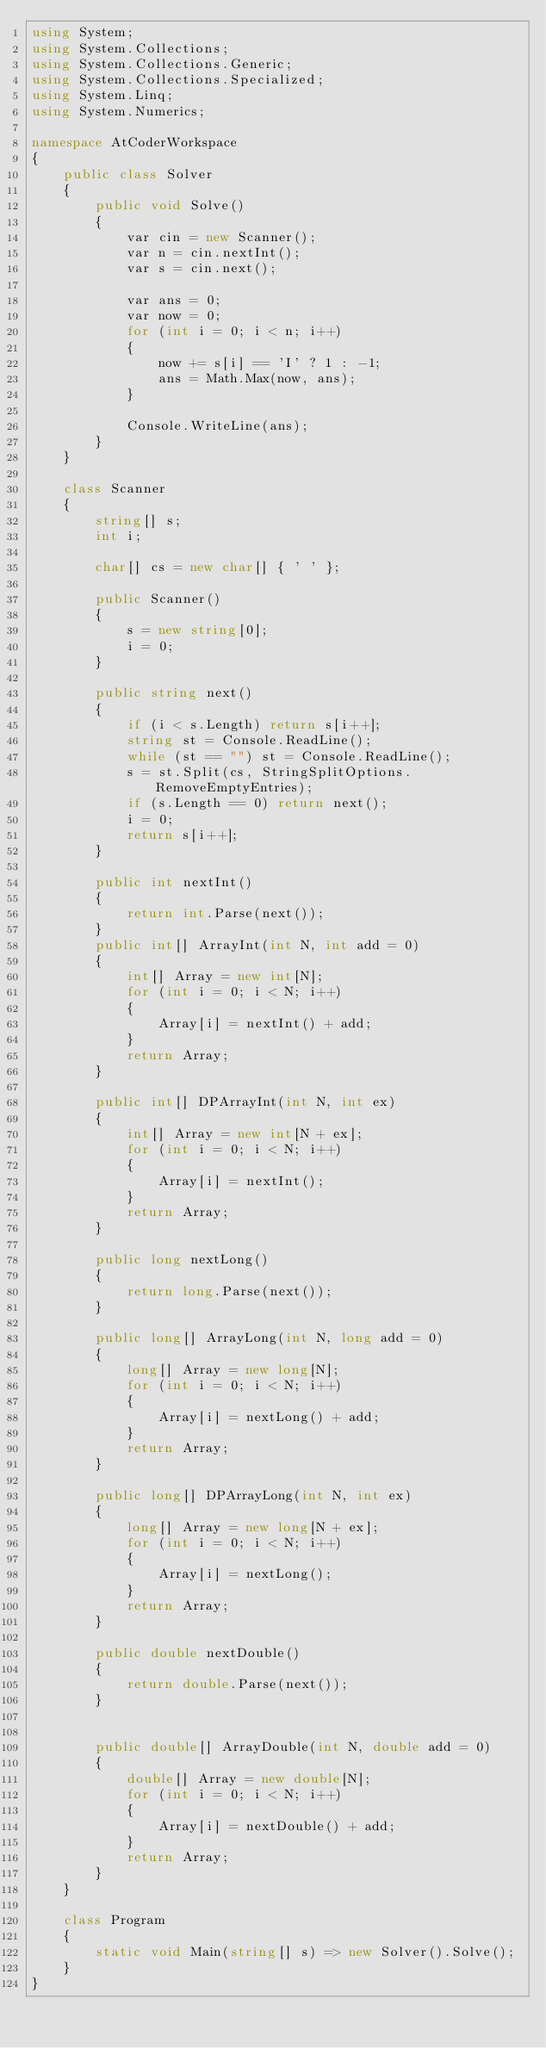<code> <loc_0><loc_0><loc_500><loc_500><_C#_>using System;
using System.Collections;
using System.Collections.Generic;
using System.Collections.Specialized;
using System.Linq;
using System.Numerics;

namespace AtCoderWorkspace
{
    public class Solver
    {
        public void Solve()
        {
            var cin = new Scanner();
            var n = cin.nextInt();
            var s = cin.next();

            var ans = 0;
            var now = 0;
            for (int i = 0; i < n; i++)
            {
                now += s[i] == 'I' ? 1 : -1;
                ans = Math.Max(now, ans);
            }

            Console.WriteLine(ans);
        }
    }    

    class Scanner
    {
        string[] s;
        int i;

        char[] cs = new char[] { ' ' };

        public Scanner()
        {
            s = new string[0];
            i = 0;
        }

        public string next()
        {
            if (i < s.Length) return s[i++];
            string st = Console.ReadLine();
            while (st == "") st = Console.ReadLine();
            s = st.Split(cs, StringSplitOptions.RemoveEmptyEntries);
            if (s.Length == 0) return next();
            i = 0;
            return s[i++];
        }

        public int nextInt()
        {
            return int.Parse(next());
        }
        public int[] ArrayInt(int N, int add = 0)
        {
            int[] Array = new int[N];
            for (int i = 0; i < N; i++)
            {
                Array[i] = nextInt() + add;
            }
            return Array;
        }

        public int[] DPArrayInt(int N, int ex)
        {
            int[] Array = new int[N + ex];
            for (int i = 0; i < N; i++)
            {
                Array[i] = nextInt();
            }
            return Array;
        }

        public long nextLong()
        {
            return long.Parse(next());
        }

        public long[] ArrayLong(int N, long add = 0)
        {
            long[] Array = new long[N];
            for (int i = 0; i < N; i++)
            {
                Array[i] = nextLong() + add;
            }
            return Array;
        }

        public long[] DPArrayLong(int N, int ex)
        {
            long[] Array = new long[N + ex];
            for (int i = 0; i < N; i++)
            {
                Array[i] = nextLong();
            }
            return Array;
        }

        public double nextDouble()
        {
            return double.Parse(next());
        }


        public double[] ArrayDouble(int N, double add = 0)
        {
            double[] Array = new double[N];
            for (int i = 0; i < N; i++)
            {
                Array[i] = nextDouble() + add;
            }
            return Array;
        }
    }

    class Program
    {
        static void Main(string[] s) => new Solver().Solve();
    }
}</code> 